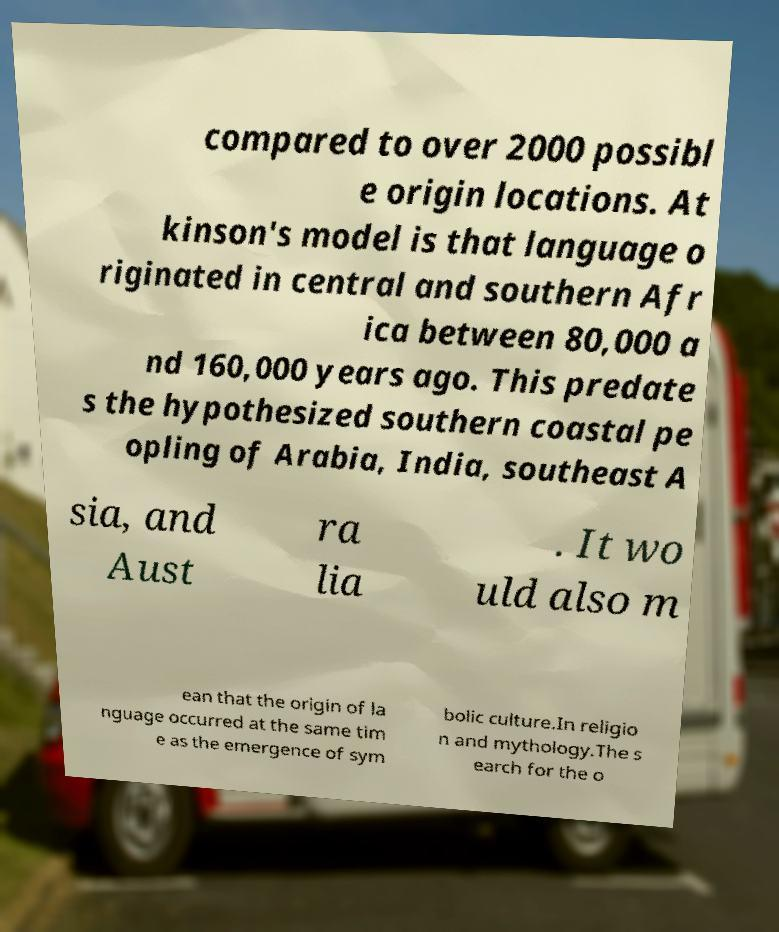Could you extract and type out the text from this image? compared to over 2000 possibl e origin locations. At kinson's model is that language o riginated in central and southern Afr ica between 80,000 a nd 160,000 years ago. This predate s the hypothesized southern coastal pe opling of Arabia, India, southeast A sia, and Aust ra lia . It wo uld also m ean that the origin of la nguage occurred at the same tim e as the emergence of sym bolic culture.In religio n and mythology.The s earch for the o 